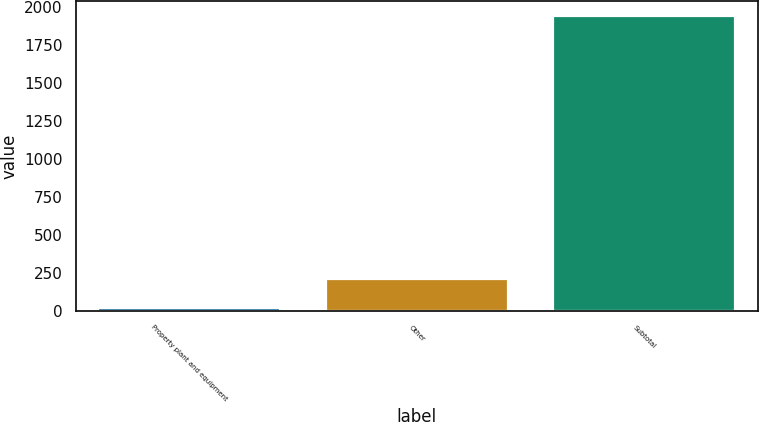Convert chart to OTSL. <chart><loc_0><loc_0><loc_500><loc_500><bar_chart><fcel>Property plant and equipment<fcel>Other<fcel>Subtotal<nl><fcel>19<fcel>211.2<fcel>1941<nl></chart> 